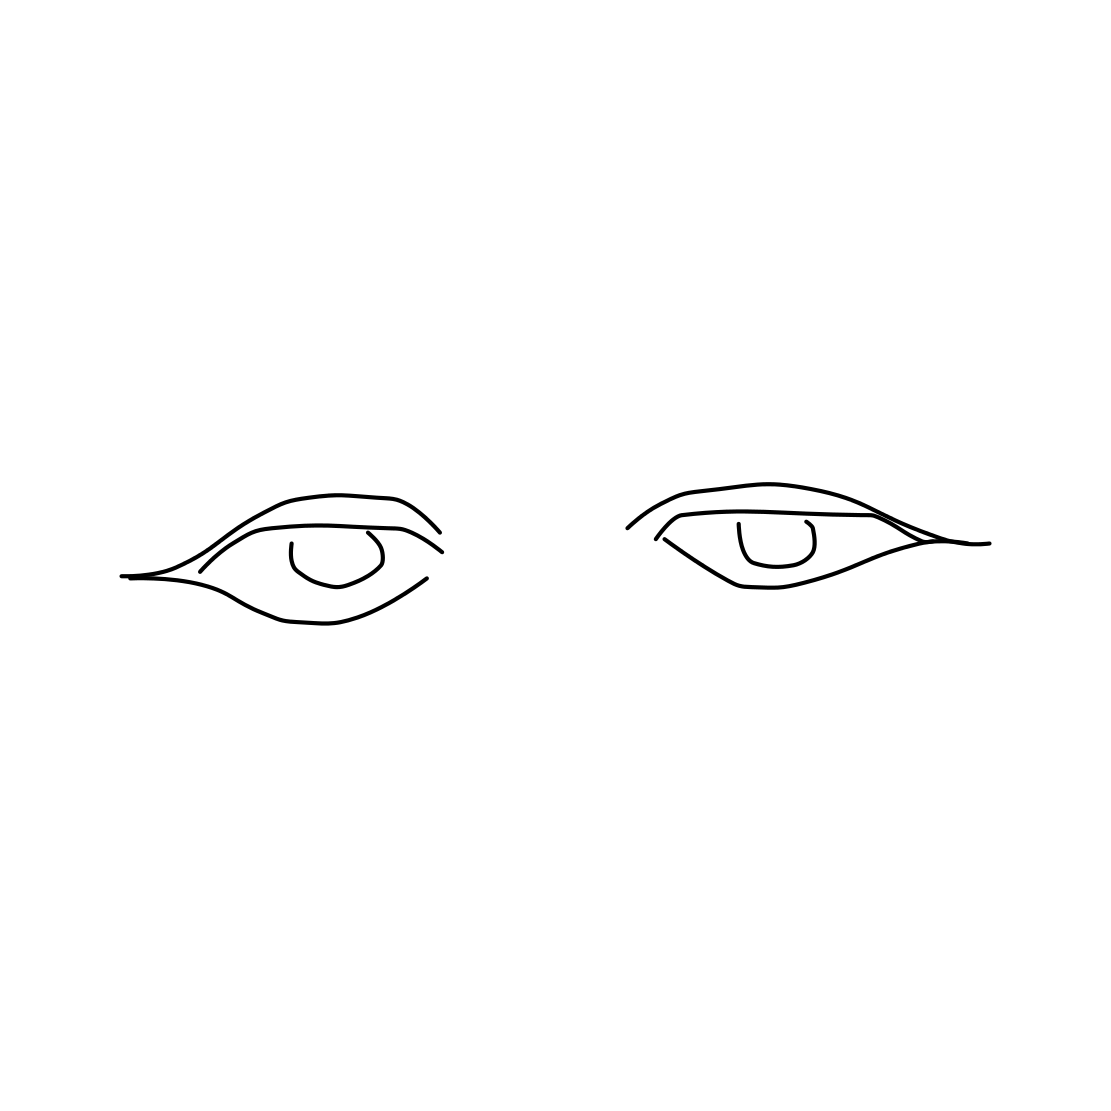How could these eyes be incorporated into a larger piece of artwork? These sketched eyes could serve as a captivating focal point in a larger portrait or character design. Their simplicity allows them to be easily blended with various artistic styles, whether the artist chooses to develop a detailed face around them or include them in a more abstract, minimalist composition. 